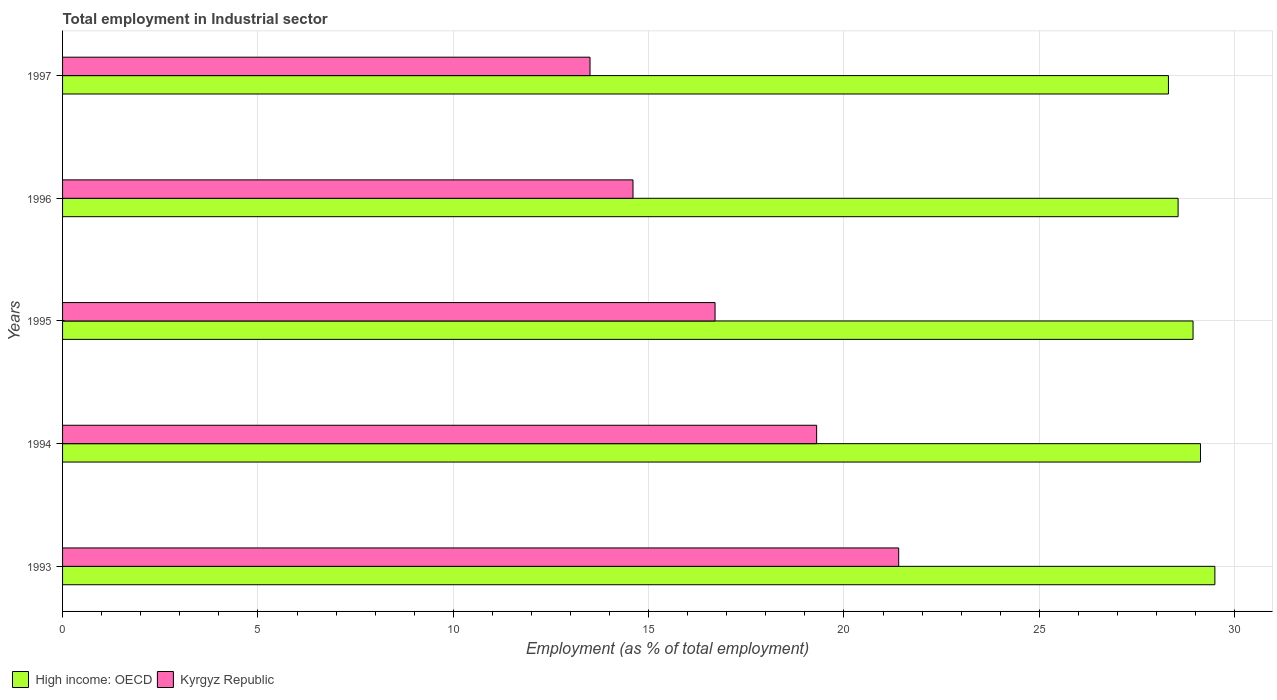How many groups of bars are there?
Your response must be concise. 5. What is the label of the 3rd group of bars from the top?
Make the answer very short. 1995. What is the employment in industrial sector in Kyrgyz Republic in 1993?
Offer a terse response. 21.4. Across all years, what is the maximum employment in industrial sector in High income: OECD?
Your answer should be compact. 29.49. In which year was the employment in industrial sector in High income: OECD minimum?
Provide a succinct answer. 1997. What is the total employment in industrial sector in Kyrgyz Republic in the graph?
Your answer should be compact. 85.5. What is the difference between the employment in industrial sector in Kyrgyz Republic in 1995 and that in 1996?
Offer a very short reply. 2.1. What is the difference between the employment in industrial sector in High income: OECD in 1993 and the employment in industrial sector in Kyrgyz Republic in 1996?
Provide a short and direct response. 14.89. What is the average employment in industrial sector in High income: OECD per year?
Your answer should be very brief. 28.88. In the year 1995, what is the difference between the employment in industrial sector in Kyrgyz Republic and employment in industrial sector in High income: OECD?
Make the answer very short. -12.23. What is the ratio of the employment in industrial sector in Kyrgyz Republic in 1996 to that in 1997?
Ensure brevity in your answer.  1.08. Is the difference between the employment in industrial sector in Kyrgyz Republic in 1993 and 1996 greater than the difference between the employment in industrial sector in High income: OECD in 1993 and 1996?
Offer a terse response. Yes. What is the difference between the highest and the second highest employment in industrial sector in High income: OECD?
Keep it short and to the point. 0.37. What is the difference between the highest and the lowest employment in industrial sector in Kyrgyz Republic?
Your answer should be compact. 7.9. What does the 1st bar from the top in 1996 represents?
Give a very brief answer. Kyrgyz Republic. What does the 1st bar from the bottom in 1994 represents?
Make the answer very short. High income: OECD. What is the difference between two consecutive major ticks on the X-axis?
Keep it short and to the point. 5. Does the graph contain grids?
Provide a succinct answer. Yes. Where does the legend appear in the graph?
Offer a very short reply. Bottom left. How many legend labels are there?
Offer a terse response. 2. How are the legend labels stacked?
Make the answer very short. Horizontal. What is the title of the graph?
Your answer should be compact. Total employment in Industrial sector. What is the label or title of the X-axis?
Your answer should be very brief. Employment (as % of total employment). What is the Employment (as % of total employment) of High income: OECD in 1993?
Give a very brief answer. 29.49. What is the Employment (as % of total employment) of Kyrgyz Republic in 1993?
Your response must be concise. 21.4. What is the Employment (as % of total employment) of High income: OECD in 1994?
Provide a short and direct response. 29.12. What is the Employment (as % of total employment) in Kyrgyz Republic in 1994?
Provide a succinct answer. 19.3. What is the Employment (as % of total employment) in High income: OECD in 1995?
Provide a short and direct response. 28.93. What is the Employment (as % of total employment) in Kyrgyz Republic in 1995?
Your answer should be very brief. 16.7. What is the Employment (as % of total employment) in High income: OECD in 1996?
Your response must be concise. 28.55. What is the Employment (as % of total employment) in Kyrgyz Republic in 1996?
Provide a short and direct response. 14.6. What is the Employment (as % of total employment) of High income: OECD in 1997?
Give a very brief answer. 28.3. What is the Employment (as % of total employment) in Kyrgyz Republic in 1997?
Your answer should be very brief. 13.5. Across all years, what is the maximum Employment (as % of total employment) in High income: OECD?
Your response must be concise. 29.49. Across all years, what is the maximum Employment (as % of total employment) of Kyrgyz Republic?
Your response must be concise. 21.4. Across all years, what is the minimum Employment (as % of total employment) of High income: OECD?
Make the answer very short. 28.3. What is the total Employment (as % of total employment) in High income: OECD in the graph?
Make the answer very short. 144.41. What is the total Employment (as % of total employment) of Kyrgyz Republic in the graph?
Offer a terse response. 85.5. What is the difference between the Employment (as % of total employment) in High income: OECD in 1993 and that in 1994?
Your response must be concise. 0.37. What is the difference between the Employment (as % of total employment) of Kyrgyz Republic in 1993 and that in 1994?
Your response must be concise. 2.1. What is the difference between the Employment (as % of total employment) in High income: OECD in 1993 and that in 1995?
Provide a short and direct response. 0.56. What is the difference between the Employment (as % of total employment) in Kyrgyz Republic in 1993 and that in 1995?
Give a very brief answer. 4.7. What is the difference between the Employment (as % of total employment) in High income: OECD in 1993 and that in 1996?
Offer a very short reply. 0.94. What is the difference between the Employment (as % of total employment) in Kyrgyz Republic in 1993 and that in 1996?
Offer a terse response. 6.8. What is the difference between the Employment (as % of total employment) in High income: OECD in 1993 and that in 1997?
Provide a short and direct response. 1.19. What is the difference between the Employment (as % of total employment) of Kyrgyz Republic in 1993 and that in 1997?
Provide a short and direct response. 7.9. What is the difference between the Employment (as % of total employment) of High income: OECD in 1994 and that in 1995?
Make the answer very short. 0.19. What is the difference between the Employment (as % of total employment) in Kyrgyz Republic in 1994 and that in 1995?
Provide a short and direct response. 2.6. What is the difference between the Employment (as % of total employment) in High income: OECD in 1994 and that in 1996?
Your answer should be very brief. 0.57. What is the difference between the Employment (as % of total employment) of High income: OECD in 1994 and that in 1997?
Offer a terse response. 0.82. What is the difference between the Employment (as % of total employment) in Kyrgyz Republic in 1994 and that in 1997?
Your answer should be compact. 5.8. What is the difference between the Employment (as % of total employment) of High income: OECD in 1995 and that in 1996?
Your response must be concise. 0.38. What is the difference between the Employment (as % of total employment) in High income: OECD in 1995 and that in 1997?
Provide a succinct answer. 0.63. What is the difference between the Employment (as % of total employment) in High income: OECD in 1996 and that in 1997?
Ensure brevity in your answer.  0.25. What is the difference between the Employment (as % of total employment) in Kyrgyz Republic in 1996 and that in 1997?
Provide a succinct answer. 1.1. What is the difference between the Employment (as % of total employment) in High income: OECD in 1993 and the Employment (as % of total employment) in Kyrgyz Republic in 1994?
Your answer should be compact. 10.19. What is the difference between the Employment (as % of total employment) in High income: OECD in 1993 and the Employment (as % of total employment) in Kyrgyz Republic in 1995?
Your answer should be compact. 12.79. What is the difference between the Employment (as % of total employment) in High income: OECD in 1993 and the Employment (as % of total employment) in Kyrgyz Republic in 1996?
Keep it short and to the point. 14.89. What is the difference between the Employment (as % of total employment) in High income: OECD in 1993 and the Employment (as % of total employment) in Kyrgyz Republic in 1997?
Provide a short and direct response. 15.99. What is the difference between the Employment (as % of total employment) of High income: OECD in 1994 and the Employment (as % of total employment) of Kyrgyz Republic in 1995?
Provide a succinct answer. 12.42. What is the difference between the Employment (as % of total employment) in High income: OECD in 1994 and the Employment (as % of total employment) in Kyrgyz Republic in 1996?
Give a very brief answer. 14.52. What is the difference between the Employment (as % of total employment) in High income: OECD in 1994 and the Employment (as % of total employment) in Kyrgyz Republic in 1997?
Your response must be concise. 15.62. What is the difference between the Employment (as % of total employment) of High income: OECD in 1995 and the Employment (as % of total employment) of Kyrgyz Republic in 1996?
Ensure brevity in your answer.  14.33. What is the difference between the Employment (as % of total employment) of High income: OECD in 1995 and the Employment (as % of total employment) of Kyrgyz Republic in 1997?
Make the answer very short. 15.43. What is the difference between the Employment (as % of total employment) in High income: OECD in 1996 and the Employment (as % of total employment) in Kyrgyz Republic in 1997?
Ensure brevity in your answer.  15.05. What is the average Employment (as % of total employment) of High income: OECD per year?
Offer a terse response. 28.88. In the year 1993, what is the difference between the Employment (as % of total employment) of High income: OECD and Employment (as % of total employment) of Kyrgyz Republic?
Your response must be concise. 8.09. In the year 1994, what is the difference between the Employment (as % of total employment) of High income: OECD and Employment (as % of total employment) of Kyrgyz Republic?
Ensure brevity in your answer.  9.82. In the year 1995, what is the difference between the Employment (as % of total employment) of High income: OECD and Employment (as % of total employment) of Kyrgyz Republic?
Keep it short and to the point. 12.23. In the year 1996, what is the difference between the Employment (as % of total employment) in High income: OECD and Employment (as % of total employment) in Kyrgyz Republic?
Give a very brief answer. 13.95. In the year 1997, what is the difference between the Employment (as % of total employment) in High income: OECD and Employment (as % of total employment) in Kyrgyz Republic?
Your response must be concise. 14.8. What is the ratio of the Employment (as % of total employment) of High income: OECD in 1993 to that in 1994?
Your answer should be compact. 1.01. What is the ratio of the Employment (as % of total employment) in Kyrgyz Republic in 1993 to that in 1994?
Offer a terse response. 1.11. What is the ratio of the Employment (as % of total employment) in High income: OECD in 1993 to that in 1995?
Keep it short and to the point. 1.02. What is the ratio of the Employment (as % of total employment) of Kyrgyz Republic in 1993 to that in 1995?
Make the answer very short. 1.28. What is the ratio of the Employment (as % of total employment) in High income: OECD in 1993 to that in 1996?
Give a very brief answer. 1.03. What is the ratio of the Employment (as % of total employment) in Kyrgyz Republic in 1993 to that in 1996?
Your answer should be very brief. 1.47. What is the ratio of the Employment (as % of total employment) of High income: OECD in 1993 to that in 1997?
Your answer should be very brief. 1.04. What is the ratio of the Employment (as % of total employment) of Kyrgyz Republic in 1993 to that in 1997?
Offer a terse response. 1.59. What is the ratio of the Employment (as % of total employment) in High income: OECD in 1994 to that in 1995?
Offer a very short reply. 1.01. What is the ratio of the Employment (as % of total employment) of Kyrgyz Republic in 1994 to that in 1995?
Keep it short and to the point. 1.16. What is the ratio of the Employment (as % of total employment) in High income: OECD in 1994 to that in 1996?
Make the answer very short. 1.02. What is the ratio of the Employment (as % of total employment) of Kyrgyz Republic in 1994 to that in 1996?
Ensure brevity in your answer.  1.32. What is the ratio of the Employment (as % of total employment) in Kyrgyz Republic in 1994 to that in 1997?
Ensure brevity in your answer.  1.43. What is the ratio of the Employment (as % of total employment) in High income: OECD in 1995 to that in 1996?
Give a very brief answer. 1.01. What is the ratio of the Employment (as % of total employment) of Kyrgyz Republic in 1995 to that in 1996?
Ensure brevity in your answer.  1.14. What is the ratio of the Employment (as % of total employment) of High income: OECD in 1995 to that in 1997?
Your answer should be very brief. 1.02. What is the ratio of the Employment (as % of total employment) of Kyrgyz Republic in 1995 to that in 1997?
Offer a very short reply. 1.24. What is the ratio of the Employment (as % of total employment) of High income: OECD in 1996 to that in 1997?
Your response must be concise. 1.01. What is the ratio of the Employment (as % of total employment) of Kyrgyz Republic in 1996 to that in 1997?
Provide a succinct answer. 1.08. What is the difference between the highest and the second highest Employment (as % of total employment) of High income: OECD?
Your answer should be very brief. 0.37. What is the difference between the highest and the lowest Employment (as % of total employment) in High income: OECD?
Offer a terse response. 1.19. What is the difference between the highest and the lowest Employment (as % of total employment) in Kyrgyz Republic?
Your answer should be very brief. 7.9. 